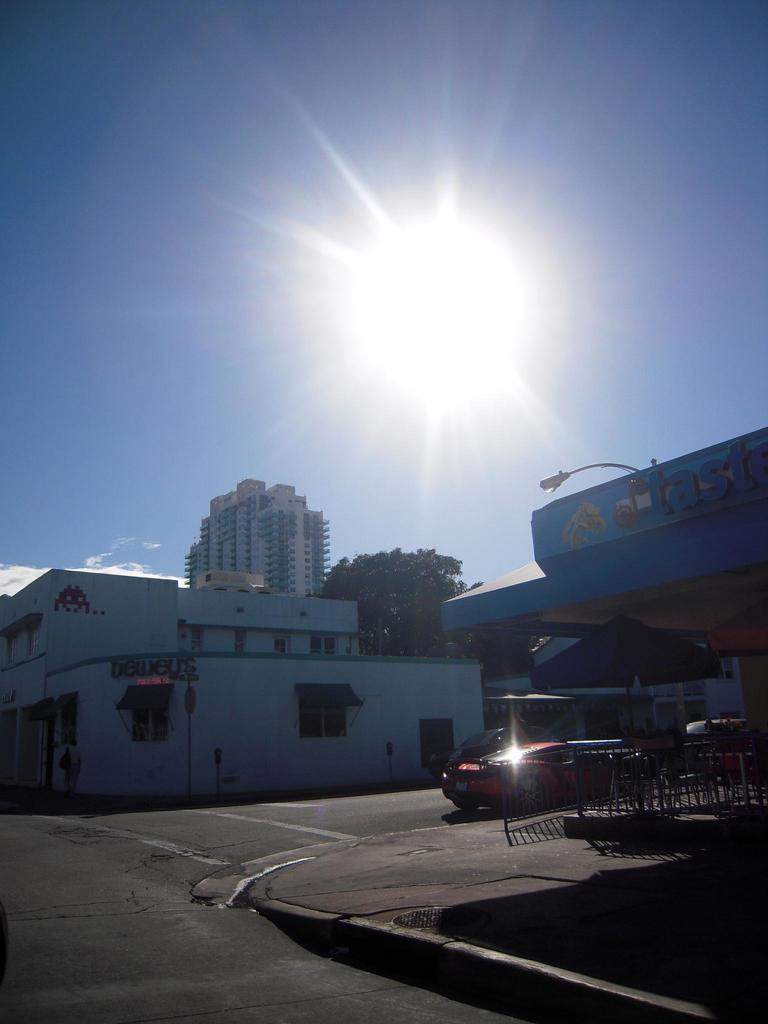What type of structures can be seen in the image? There are buildings in the image. What natural elements are present in the image? There are trees in the image. Can you describe the lighting conditions in the image? There is light and sunlight in the image. What architectural features can be seen in the image? There are grilles in the image. What man-made objects are visible in the image? There are vehicles in the image. What is the primary surface for transportation in the image? There is a road in the image. What part of the natural environment is visible in the image? The sky is visible in the image. Are there any living beings in the image? Yes, there is a person in the image. What else can be seen in the image besides the mentioned elements? There are objects in the image. Where is the toothbrush located in the image? There is no toothbrush present in the image. What type of form does the bee take in the image? There is no bee present in the image. 